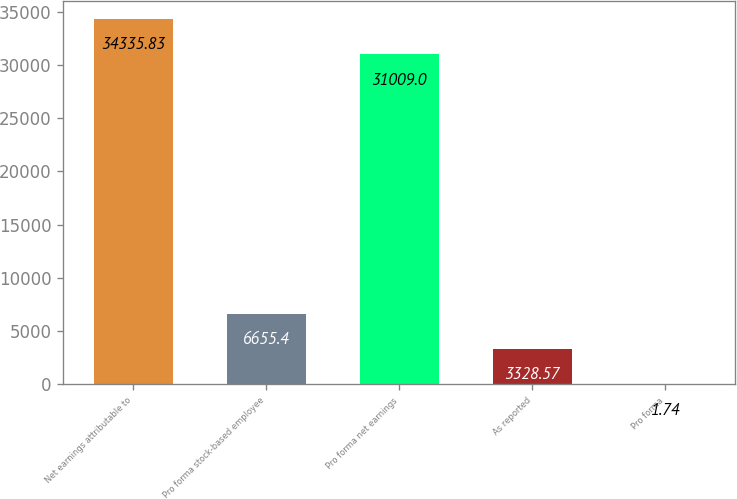<chart> <loc_0><loc_0><loc_500><loc_500><bar_chart><fcel>Net earnings attributable to<fcel>Pro forma stock-based employee<fcel>Pro forma net earnings<fcel>As reported<fcel>Pro forma<nl><fcel>34335.8<fcel>6655.4<fcel>31009<fcel>3328.57<fcel>1.74<nl></chart> 